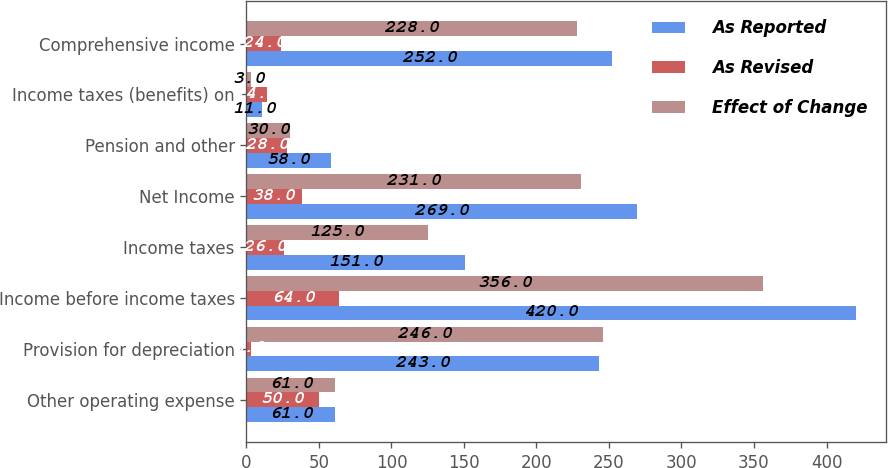<chart> <loc_0><loc_0><loc_500><loc_500><stacked_bar_chart><ecel><fcel>Other operating expense<fcel>Provision for depreciation<fcel>Income before income taxes<fcel>Income taxes<fcel>Net Income<fcel>Pension and other<fcel>Income taxes (benefits) on<fcel>Comprehensive income<nl><fcel>As Reported<fcel>61<fcel>243<fcel>420<fcel>151<fcel>269<fcel>58<fcel>11<fcel>252<nl><fcel>As Revised<fcel>50<fcel>3<fcel>64<fcel>26<fcel>38<fcel>28<fcel>14<fcel>24<nl><fcel>Effect of Change<fcel>61<fcel>246<fcel>356<fcel>125<fcel>231<fcel>30<fcel>3<fcel>228<nl></chart> 